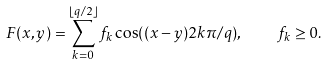Convert formula to latex. <formula><loc_0><loc_0><loc_500><loc_500>F ( x , y ) = \sum _ { k = 0 } ^ { \lfloor q / 2 \rfloor } f _ { k } \cos ( ( x - y ) 2 k \pi / q ) , \quad f _ { k } \geq 0 .</formula> 